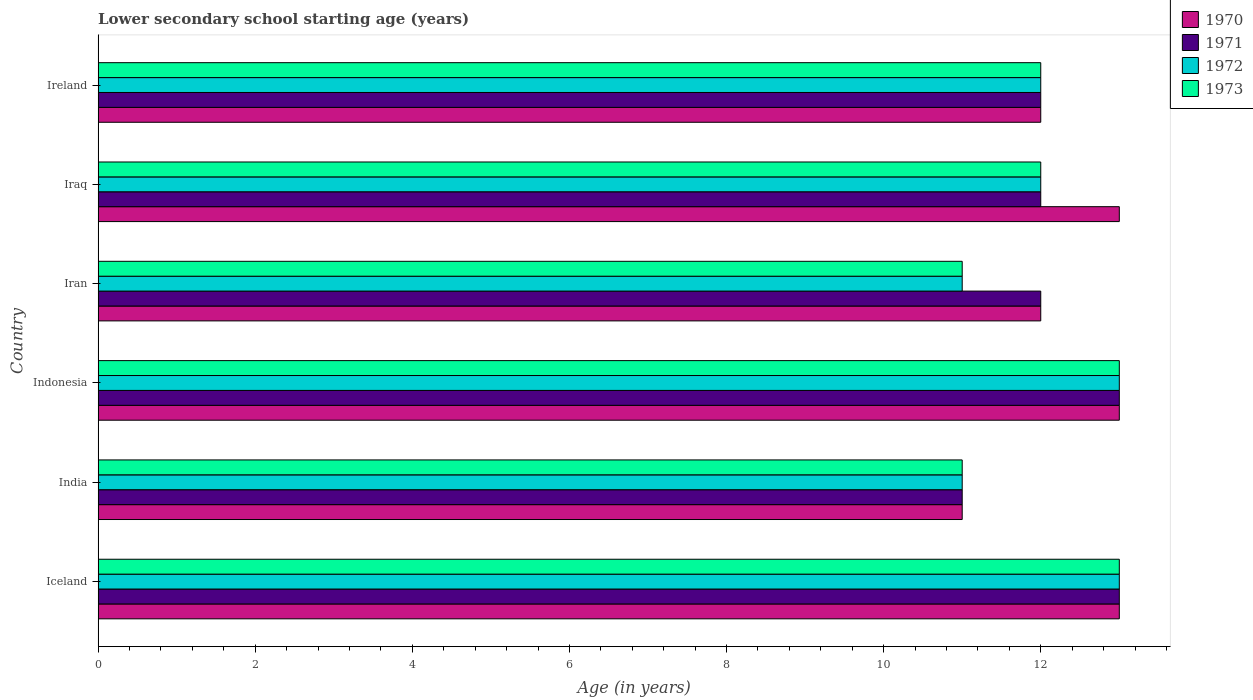How many different coloured bars are there?
Offer a terse response. 4. How many groups of bars are there?
Provide a succinct answer. 6. Are the number of bars per tick equal to the number of legend labels?
Offer a terse response. Yes. Are the number of bars on each tick of the Y-axis equal?
Provide a short and direct response. Yes. How many bars are there on the 5th tick from the bottom?
Your response must be concise. 4. In how many cases, is the number of bars for a given country not equal to the number of legend labels?
Give a very brief answer. 0. Across all countries, what is the maximum lower secondary school starting age of children in 1971?
Your response must be concise. 13. Across all countries, what is the minimum lower secondary school starting age of children in 1970?
Offer a very short reply. 11. In which country was the lower secondary school starting age of children in 1972 maximum?
Provide a short and direct response. Iceland. In which country was the lower secondary school starting age of children in 1972 minimum?
Your answer should be very brief. India. What is the average lower secondary school starting age of children in 1971 per country?
Keep it short and to the point. 12.17. What is the difference between the lower secondary school starting age of children in 1973 and lower secondary school starting age of children in 1971 in Indonesia?
Ensure brevity in your answer.  0. In how many countries, is the lower secondary school starting age of children in 1972 greater than 4.4 years?
Keep it short and to the point. 6. Is the lower secondary school starting age of children in 1971 in India less than that in Iran?
Provide a short and direct response. Yes. Is the difference between the lower secondary school starting age of children in 1973 in India and Iran greater than the difference between the lower secondary school starting age of children in 1971 in India and Iran?
Your response must be concise. Yes. What is the difference between the highest and the second highest lower secondary school starting age of children in 1972?
Offer a very short reply. 0. In how many countries, is the lower secondary school starting age of children in 1973 greater than the average lower secondary school starting age of children in 1973 taken over all countries?
Offer a terse response. 2. What does the 1st bar from the top in Indonesia represents?
Offer a terse response. 1973. What does the 4th bar from the bottom in Iran represents?
Provide a succinct answer. 1973. Is it the case that in every country, the sum of the lower secondary school starting age of children in 1973 and lower secondary school starting age of children in 1971 is greater than the lower secondary school starting age of children in 1970?
Give a very brief answer. Yes. Are all the bars in the graph horizontal?
Give a very brief answer. Yes. How many countries are there in the graph?
Make the answer very short. 6. What is the difference between two consecutive major ticks on the X-axis?
Keep it short and to the point. 2. Are the values on the major ticks of X-axis written in scientific E-notation?
Your response must be concise. No. Where does the legend appear in the graph?
Your response must be concise. Top right. How many legend labels are there?
Give a very brief answer. 4. What is the title of the graph?
Offer a very short reply. Lower secondary school starting age (years). What is the label or title of the X-axis?
Provide a succinct answer. Age (in years). What is the label or title of the Y-axis?
Provide a succinct answer. Country. What is the Age (in years) of 1972 in Iceland?
Make the answer very short. 13. What is the Age (in years) of 1970 in India?
Give a very brief answer. 11. What is the Age (in years) in 1971 in India?
Your answer should be compact. 11. What is the Age (in years) of 1972 in India?
Provide a succinct answer. 11. What is the Age (in years) in 1973 in India?
Offer a very short reply. 11. What is the Age (in years) of 1971 in Iran?
Ensure brevity in your answer.  12. What is the Age (in years) in 1972 in Iran?
Your answer should be very brief. 11. What is the Age (in years) of 1973 in Iran?
Provide a succinct answer. 11. What is the Age (in years) in 1970 in Ireland?
Give a very brief answer. 12. Across all countries, what is the maximum Age (in years) of 1970?
Provide a short and direct response. 13. Across all countries, what is the maximum Age (in years) in 1972?
Make the answer very short. 13. Across all countries, what is the maximum Age (in years) of 1973?
Provide a succinct answer. 13. Across all countries, what is the minimum Age (in years) of 1972?
Provide a short and direct response. 11. What is the total Age (in years) in 1970 in the graph?
Provide a short and direct response. 74. What is the total Age (in years) of 1971 in the graph?
Your answer should be very brief. 73. What is the total Age (in years) in 1972 in the graph?
Ensure brevity in your answer.  72. What is the difference between the Age (in years) of 1970 in Iceland and that in India?
Make the answer very short. 2. What is the difference between the Age (in years) in 1972 in Iceland and that in India?
Keep it short and to the point. 2. What is the difference between the Age (in years) in 1970 in Iceland and that in Indonesia?
Make the answer very short. 0. What is the difference between the Age (in years) in 1972 in Iceland and that in Indonesia?
Your response must be concise. 0. What is the difference between the Age (in years) of 1971 in Iceland and that in Iran?
Provide a succinct answer. 1. What is the difference between the Age (in years) in 1970 in Iceland and that in Iraq?
Your answer should be very brief. 0. What is the difference between the Age (in years) in 1972 in Iceland and that in Iraq?
Your answer should be very brief. 1. What is the difference between the Age (in years) of 1973 in Iceland and that in Iraq?
Ensure brevity in your answer.  1. What is the difference between the Age (in years) of 1972 in India and that in Indonesia?
Give a very brief answer. -2. What is the difference between the Age (in years) in 1970 in India and that in Iran?
Offer a terse response. -1. What is the difference between the Age (in years) of 1971 in India and that in Iran?
Offer a very short reply. -1. What is the difference between the Age (in years) of 1970 in India and that in Ireland?
Provide a succinct answer. -1. What is the difference between the Age (in years) of 1973 in India and that in Ireland?
Keep it short and to the point. -1. What is the difference between the Age (in years) in 1971 in Indonesia and that in Iran?
Your answer should be compact. 1. What is the difference between the Age (in years) of 1972 in Indonesia and that in Iran?
Provide a succinct answer. 2. What is the difference between the Age (in years) in 1970 in Indonesia and that in Iraq?
Offer a terse response. 0. What is the difference between the Age (in years) in 1970 in Indonesia and that in Ireland?
Ensure brevity in your answer.  1. What is the difference between the Age (in years) of 1973 in Indonesia and that in Ireland?
Your response must be concise. 1. What is the difference between the Age (in years) of 1970 in Iran and that in Iraq?
Keep it short and to the point. -1. What is the difference between the Age (in years) in 1971 in Iran and that in Iraq?
Provide a short and direct response. 0. What is the difference between the Age (in years) in 1972 in Iran and that in Iraq?
Make the answer very short. -1. What is the difference between the Age (in years) in 1973 in Iran and that in Iraq?
Make the answer very short. -1. What is the difference between the Age (in years) in 1970 in Iran and that in Ireland?
Your answer should be compact. 0. What is the difference between the Age (in years) in 1971 in Iran and that in Ireland?
Your answer should be compact. 0. What is the difference between the Age (in years) of 1972 in Iran and that in Ireland?
Your answer should be compact. -1. What is the difference between the Age (in years) of 1973 in Iran and that in Ireland?
Make the answer very short. -1. What is the difference between the Age (in years) of 1971 in Iraq and that in Ireland?
Ensure brevity in your answer.  0. What is the difference between the Age (in years) in 1972 in Iraq and that in Ireland?
Make the answer very short. 0. What is the difference between the Age (in years) of 1970 in Iceland and the Age (in years) of 1971 in India?
Offer a terse response. 2. What is the difference between the Age (in years) in 1970 in Iceland and the Age (in years) in 1972 in India?
Keep it short and to the point. 2. What is the difference between the Age (in years) in 1971 in Iceland and the Age (in years) in 1973 in India?
Provide a short and direct response. 2. What is the difference between the Age (in years) in 1970 in Iceland and the Age (in years) in 1971 in Indonesia?
Keep it short and to the point. 0. What is the difference between the Age (in years) in 1970 in Iceland and the Age (in years) in 1973 in Indonesia?
Your answer should be very brief. 0. What is the difference between the Age (in years) of 1971 in Iceland and the Age (in years) of 1972 in Indonesia?
Give a very brief answer. 0. What is the difference between the Age (in years) in 1970 in Iceland and the Age (in years) in 1971 in Iran?
Your response must be concise. 1. What is the difference between the Age (in years) in 1971 in Iceland and the Age (in years) in 1973 in Iran?
Your response must be concise. 2. What is the difference between the Age (in years) of 1970 in Iceland and the Age (in years) of 1971 in Iraq?
Your answer should be very brief. 1. What is the difference between the Age (in years) in 1970 in Iceland and the Age (in years) in 1972 in Iraq?
Provide a short and direct response. 1. What is the difference between the Age (in years) in 1970 in Iceland and the Age (in years) in 1973 in Iraq?
Provide a short and direct response. 1. What is the difference between the Age (in years) of 1971 in Iceland and the Age (in years) of 1973 in Iraq?
Make the answer very short. 1. What is the difference between the Age (in years) in 1972 in Iceland and the Age (in years) in 1973 in Iraq?
Offer a very short reply. 1. What is the difference between the Age (in years) in 1970 in Iceland and the Age (in years) in 1971 in Ireland?
Offer a very short reply. 1. What is the difference between the Age (in years) in 1970 in Iceland and the Age (in years) in 1972 in Ireland?
Your response must be concise. 1. What is the difference between the Age (in years) in 1970 in India and the Age (in years) in 1971 in Indonesia?
Give a very brief answer. -2. What is the difference between the Age (in years) in 1970 in India and the Age (in years) in 1972 in Indonesia?
Provide a succinct answer. -2. What is the difference between the Age (in years) in 1971 in India and the Age (in years) in 1972 in Indonesia?
Your answer should be compact. -2. What is the difference between the Age (in years) of 1972 in India and the Age (in years) of 1973 in Indonesia?
Offer a terse response. -2. What is the difference between the Age (in years) of 1970 in India and the Age (in years) of 1971 in Iran?
Ensure brevity in your answer.  -1. What is the difference between the Age (in years) of 1972 in India and the Age (in years) of 1973 in Iran?
Your response must be concise. 0. What is the difference between the Age (in years) in 1971 in India and the Age (in years) in 1972 in Iraq?
Keep it short and to the point. -1. What is the difference between the Age (in years) of 1970 in India and the Age (in years) of 1971 in Ireland?
Your answer should be compact. -1. What is the difference between the Age (in years) of 1970 in India and the Age (in years) of 1972 in Ireland?
Offer a very short reply. -1. What is the difference between the Age (in years) of 1971 in India and the Age (in years) of 1972 in Ireland?
Give a very brief answer. -1. What is the difference between the Age (in years) of 1972 in India and the Age (in years) of 1973 in Ireland?
Your answer should be compact. -1. What is the difference between the Age (in years) of 1970 in Indonesia and the Age (in years) of 1973 in Iran?
Provide a short and direct response. 2. What is the difference between the Age (in years) in 1971 in Indonesia and the Age (in years) in 1972 in Iran?
Give a very brief answer. 2. What is the difference between the Age (in years) of 1971 in Indonesia and the Age (in years) of 1973 in Iran?
Give a very brief answer. 2. What is the difference between the Age (in years) in 1972 in Indonesia and the Age (in years) in 1973 in Iran?
Your answer should be compact. 2. What is the difference between the Age (in years) of 1970 in Indonesia and the Age (in years) of 1973 in Iraq?
Provide a short and direct response. 1. What is the difference between the Age (in years) in 1970 in Indonesia and the Age (in years) in 1971 in Ireland?
Ensure brevity in your answer.  1. What is the difference between the Age (in years) of 1970 in Indonesia and the Age (in years) of 1973 in Ireland?
Give a very brief answer. 1. What is the difference between the Age (in years) in 1971 in Indonesia and the Age (in years) in 1973 in Ireland?
Ensure brevity in your answer.  1. What is the difference between the Age (in years) in 1972 in Indonesia and the Age (in years) in 1973 in Ireland?
Provide a succinct answer. 1. What is the difference between the Age (in years) in 1970 in Iran and the Age (in years) in 1971 in Iraq?
Your answer should be compact. 0. What is the difference between the Age (in years) of 1970 in Iran and the Age (in years) of 1972 in Iraq?
Keep it short and to the point. 0. What is the difference between the Age (in years) in 1970 in Iran and the Age (in years) in 1971 in Ireland?
Offer a terse response. 0. What is the difference between the Age (in years) of 1970 in Iran and the Age (in years) of 1972 in Ireland?
Give a very brief answer. 0. What is the difference between the Age (in years) of 1971 in Iran and the Age (in years) of 1972 in Ireland?
Your answer should be compact. 0. What is the difference between the Age (in years) in 1971 in Iran and the Age (in years) in 1973 in Ireland?
Keep it short and to the point. 0. What is the difference between the Age (in years) of 1972 in Iran and the Age (in years) of 1973 in Ireland?
Make the answer very short. -1. What is the difference between the Age (in years) in 1970 in Iraq and the Age (in years) in 1971 in Ireland?
Your answer should be very brief. 1. What is the difference between the Age (in years) in 1970 in Iraq and the Age (in years) in 1972 in Ireland?
Keep it short and to the point. 1. What is the difference between the Age (in years) in 1970 in Iraq and the Age (in years) in 1973 in Ireland?
Offer a very short reply. 1. What is the average Age (in years) of 1970 per country?
Ensure brevity in your answer.  12.33. What is the average Age (in years) of 1971 per country?
Make the answer very short. 12.17. What is the average Age (in years) of 1972 per country?
Provide a short and direct response. 12. What is the difference between the Age (in years) of 1970 and Age (in years) of 1973 in Iceland?
Give a very brief answer. 0. What is the difference between the Age (in years) of 1970 and Age (in years) of 1971 in India?
Keep it short and to the point. 0. What is the difference between the Age (in years) of 1970 and Age (in years) of 1973 in India?
Your answer should be very brief. 0. What is the difference between the Age (in years) in 1971 and Age (in years) in 1972 in India?
Offer a very short reply. 0. What is the difference between the Age (in years) of 1972 and Age (in years) of 1973 in India?
Offer a very short reply. 0. What is the difference between the Age (in years) in 1970 and Age (in years) in 1973 in Indonesia?
Your answer should be compact. 0. What is the difference between the Age (in years) of 1971 and Age (in years) of 1972 in Indonesia?
Offer a terse response. 0. What is the difference between the Age (in years) in 1972 and Age (in years) in 1973 in Indonesia?
Provide a short and direct response. 0. What is the difference between the Age (in years) in 1970 and Age (in years) in 1971 in Iran?
Offer a very short reply. 0. What is the difference between the Age (in years) of 1971 and Age (in years) of 1973 in Iran?
Ensure brevity in your answer.  1. What is the difference between the Age (in years) in 1972 and Age (in years) in 1973 in Iran?
Provide a succinct answer. 0. What is the difference between the Age (in years) of 1970 and Age (in years) of 1972 in Iraq?
Ensure brevity in your answer.  1. What is the difference between the Age (in years) in 1970 and Age (in years) in 1973 in Iraq?
Provide a short and direct response. 1. What is the difference between the Age (in years) in 1971 and Age (in years) in 1972 in Iraq?
Your answer should be very brief. 0. What is the difference between the Age (in years) in 1971 and Age (in years) in 1973 in Iraq?
Provide a short and direct response. 0. What is the difference between the Age (in years) of 1972 and Age (in years) of 1973 in Iraq?
Provide a succinct answer. 0. What is the difference between the Age (in years) in 1970 and Age (in years) in 1973 in Ireland?
Your response must be concise. 0. What is the difference between the Age (in years) in 1971 and Age (in years) in 1973 in Ireland?
Make the answer very short. 0. What is the ratio of the Age (in years) of 1970 in Iceland to that in India?
Make the answer very short. 1.18. What is the ratio of the Age (in years) in 1971 in Iceland to that in India?
Provide a short and direct response. 1.18. What is the ratio of the Age (in years) of 1972 in Iceland to that in India?
Offer a very short reply. 1.18. What is the ratio of the Age (in years) of 1973 in Iceland to that in India?
Keep it short and to the point. 1.18. What is the ratio of the Age (in years) in 1970 in Iceland to that in Indonesia?
Provide a short and direct response. 1. What is the ratio of the Age (in years) in 1971 in Iceland to that in Indonesia?
Provide a succinct answer. 1. What is the ratio of the Age (in years) of 1973 in Iceland to that in Indonesia?
Offer a very short reply. 1. What is the ratio of the Age (in years) in 1971 in Iceland to that in Iran?
Offer a very short reply. 1.08. What is the ratio of the Age (in years) in 1972 in Iceland to that in Iran?
Provide a succinct answer. 1.18. What is the ratio of the Age (in years) in 1973 in Iceland to that in Iran?
Your response must be concise. 1.18. What is the ratio of the Age (in years) of 1970 in Iceland to that in Iraq?
Make the answer very short. 1. What is the ratio of the Age (in years) of 1971 in Iceland to that in Iraq?
Ensure brevity in your answer.  1.08. What is the ratio of the Age (in years) of 1970 in Iceland to that in Ireland?
Keep it short and to the point. 1.08. What is the ratio of the Age (in years) in 1971 in Iceland to that in Ireland?
Provide a succinct answer. 1.08. What is the ratio of the Age (in years) in 1972 in Iceland to that in Ireland?
Offer a very short reply. 1.08. What is the ratio of the Age (in years) of 1970 in India to that in Indonesia?
Offer a very short reply. 0.85. What is the ratio of the Age (in years) of 1971 in India to that in Indonesia?
Offer a terse response. 0.85. What is the ratio of the Age (in years) of 1972 in India to that in Indonesia?
Provide a succinct answer. 0.85. What is the ratio of the Age (in years) in 1973 in India to that in Indonesia?
Ensure brevity in your answer.  0.85. What is the ratio of the Age (in years) of 1973 in India to that in Iran?
Offer a very short reply. 1. What is the ratio of the Age (in years) of 1970 in India to that in Iraq?
Give a very brief answer. 0.85. What is the ratio of the Age (in years) of 1971 in India to that in Iraq?
Give a very brief answer. 0.92. What is the ratio of the Age (in years) of 1973 in India to that in Iraq?
Offer a very short reply. 0.92. What is the ratio of the Age (in years) in 1971 in India to that in Ireland?
Ensure brevity in your answer.  0.92. What is the ratio of the Age (in years) in 1970 in Indonesia to that in Iran?
Offer a terse response. 1.08. What is the ratio of the Age (in years) of 1971 in Indonesia to that in Iran?
Offer a very short reply. 1.08. What is the ratio of the Age (in years) in 1972 in Indonesia to that in Iran?
Provide a succinct answer. 1.18. What is the ratio of the Age (in years) in 1973 in Indonesia to that in Iran?
Your response must be concise. 1.18. What is the ratio of the Age (in years) in 1970 in Indonesia to that in Iraq?
Keep it short and to the point. 1. What is the ratio of the Age (in years) in 1973 in Indonesia to that in Iraq?
Provide a succinct answer. 1.08. What is the ratio of the Age (in years) of 1973 in Indonesia to that in Ireland?
Offer a terse response. 1.08. What is the ratio of the Age (in years) in 1973 in Iran to that in Iraq?
Your answer should be compact. 0.92. What is the ratio of the Age (in years) of 1970 in Iran to that in Ireland?
Offer a very short reply. 1. What is the ratio of the Age (in years) of 1973 in Iran to that in Ireland?
Offer a terse response. 0.92. What is the ratio of the Age (in years) in 1970 in Iraq to that in Ireland?
Ensure brevity in your answer.  1.08. What is the ratio of the Age (in years) of 1971 in Iraq to that in Ireland?
Make the answer very short. 1. What is the ratio of the Age (in years) in 1973 in Iraq to that in Ireland?
Your answer should be very brief. 1. What is the difference between the highest and the second highest Age (in years) of 1970?
Give a very brief answer. 0. What is the difference between the highest and the lowest Age (in years) in 1973?
Give a very brief answer. 2. 